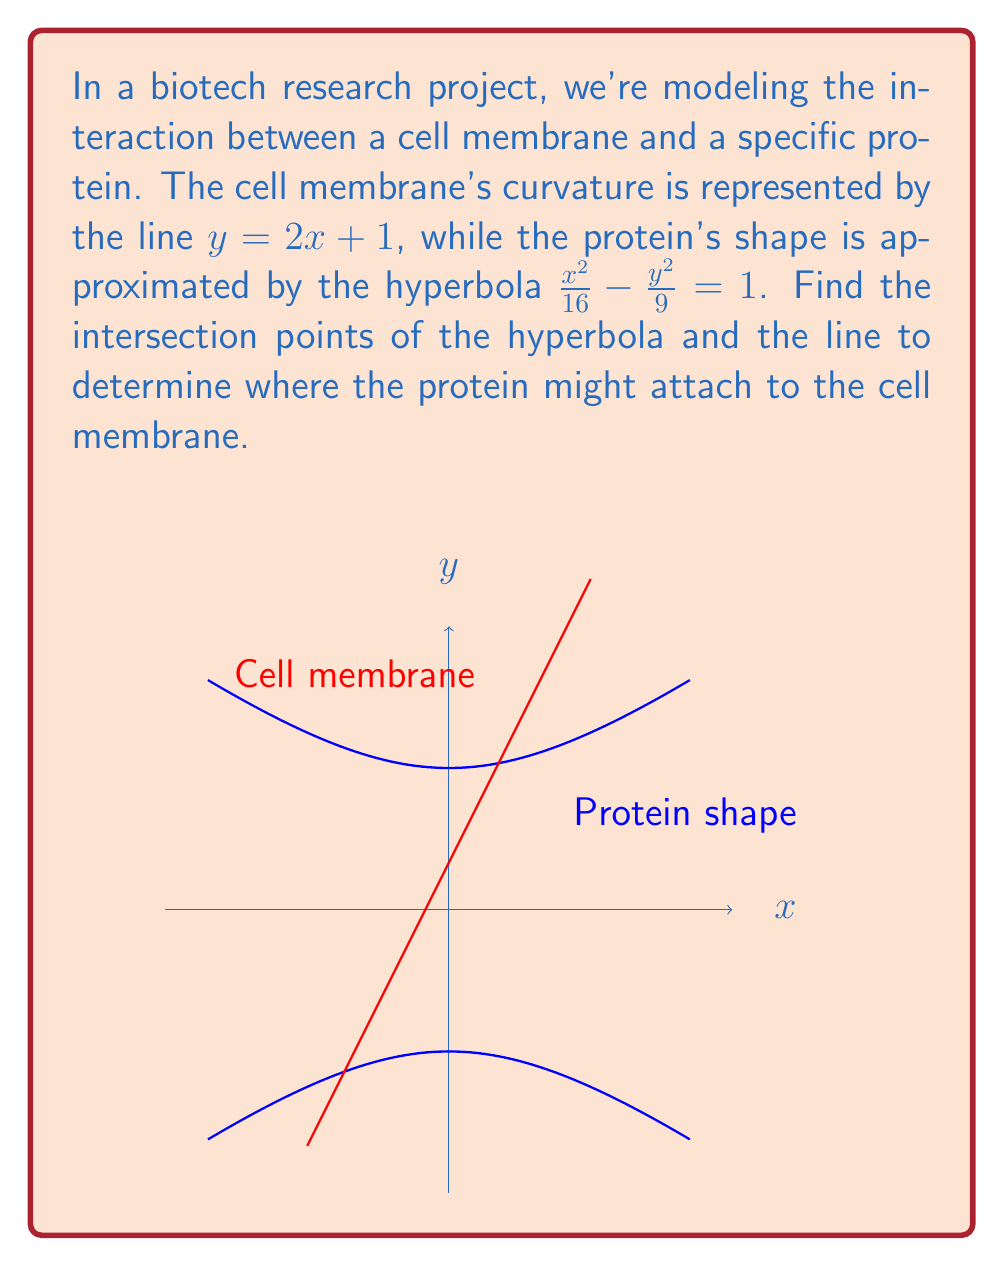Can you answer this question? Let's solve this step-by-step:

1) We have two equations:
   Line (cell membrane): $y = 2x + 1$
   Hyperbola (protein shape): $\frac{x^2}{16} - \frac{y^2}{9} = 1$

2) To find the intersection points, we need to solve these equations simultaneously. Let's substitute the line equation into the hyperbola equation:

   $\frac{x^2}{16} - \frac{(2x + 1)^2}{9} = 1$

3) Expand the squared term:
   $\frac{x^2}{16} - \frac{4x^2 + 4x + 1}{9} = 1$

4) Multiply all terms by 144 to eliminate fractions:
   $9x^2 - 64x^2 - 64x - 16 = 144$

5) Simplify:
   $-55x^2 - 64x - 160 = 0$

6) Divide all terms by -1:
   $55x^2 + 64x + 160 = 0$

7) This is a quadratic equation. We can solve it using the quadratic formula:
   $x = \frac{-b \pm \sqrt{b^2 - 4ac}}{2a}$

   Where $a = 55$, $b = 64$, and $c = 160$

8) Substituting these values:
   $x = \frac{-64 \pm \sqrt{64^2 - 4(55)(160)}}{2(55)}$

9) Simplify:
   $x = \frac{-64 \pm \sqrt{4096 - 35200}}{110} = \frac{-64 \pm \sqrt{-31104}}{110}$

10) Since the discriminant is negative, there are no real solutions. This means the line and the hyperbola do not intersect.
Answer: No real intersection points exist. 